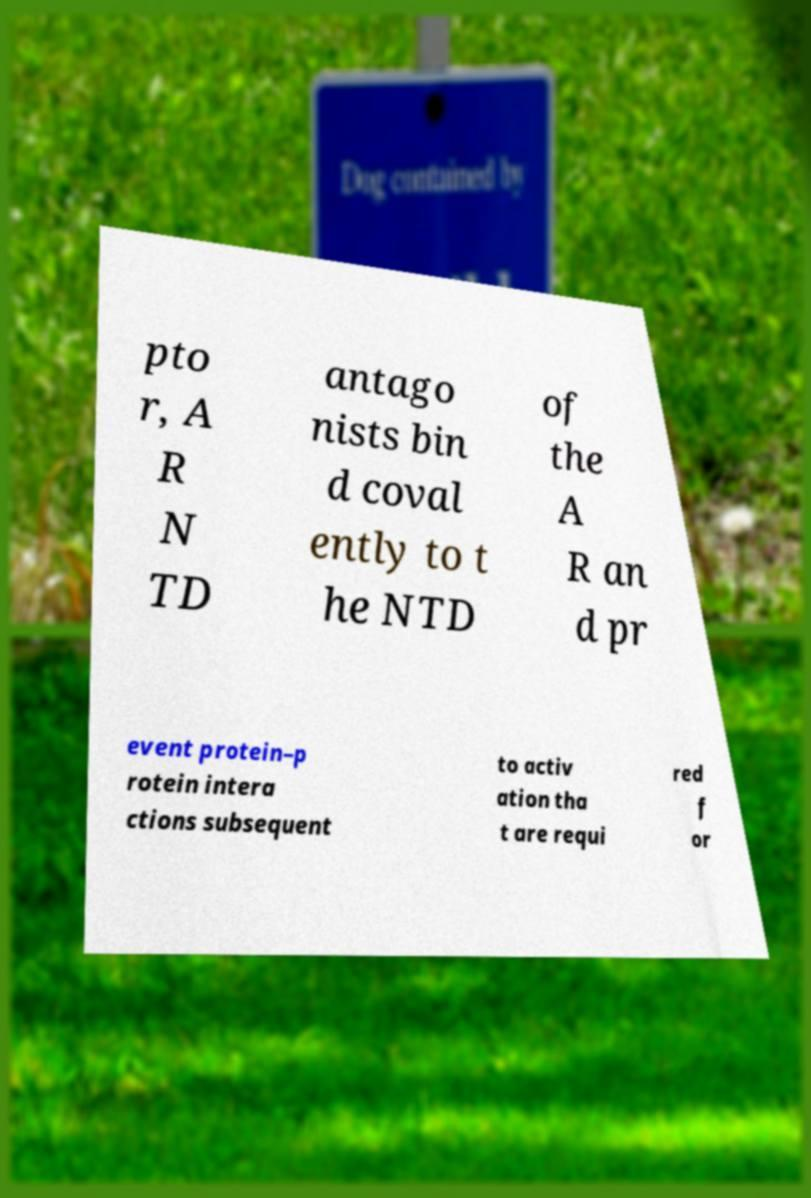Can you read and provide the text displayed in the image?This photo seems to have some interesting text. Can you extract and type it out for me? pto r, A R N TD antago nists bin d coval ently to t he NTD of the A R an d pr event protein–p rotein intera ctions subsequent to activ ation tha t are requi red f or 